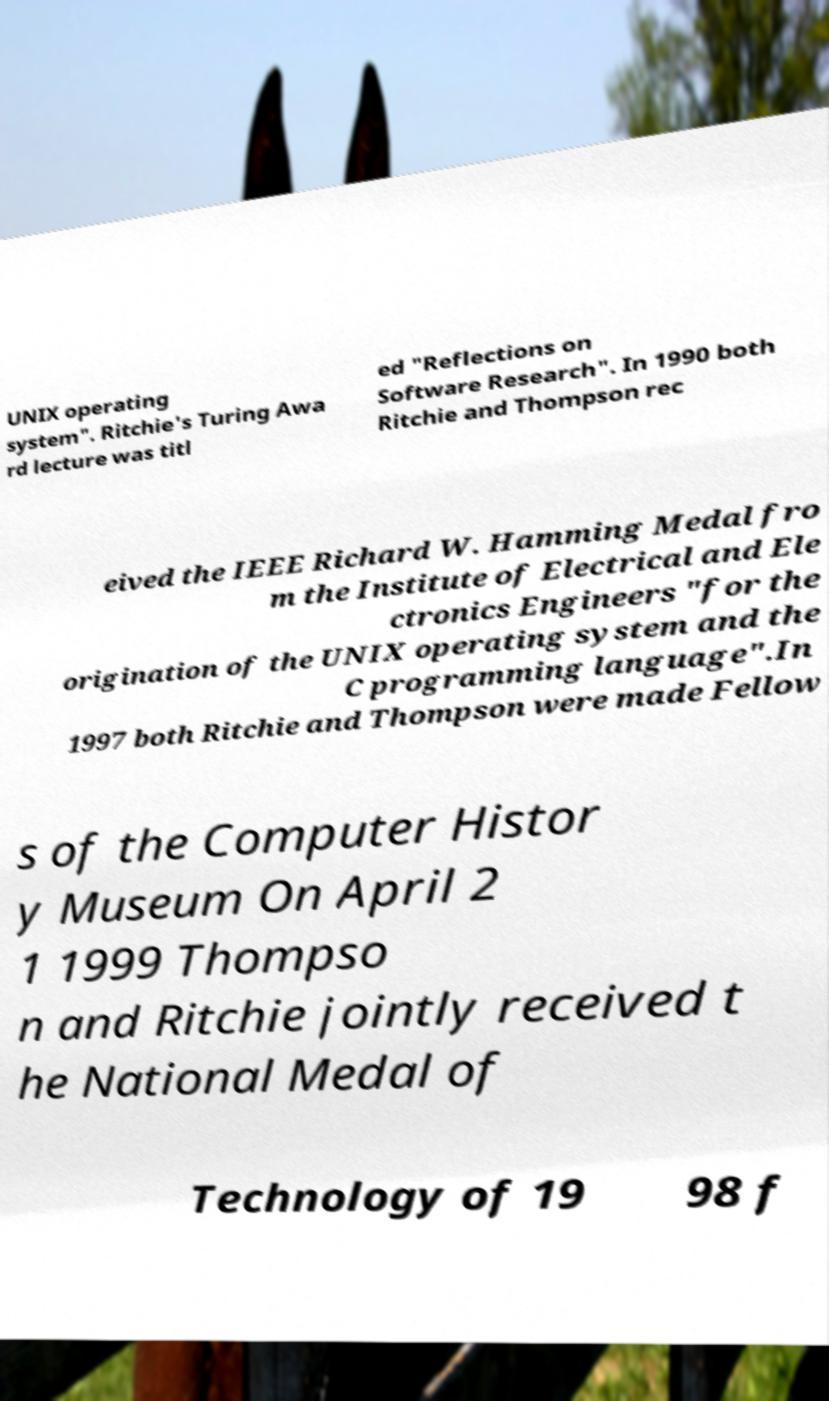Can you accurately transcribe the text from the provided image for me? UNIX operating system". Ritchie's Turing Awa rd lecture was titl ed "Reflections on Software Research". In 1990 both Ritchie and Thompson rec eived the IEEE Richard W. Hamming Medal fro m the Institute of Electrical and Ele ctronics Engineers "for the origination of the UNIX operating system and the C programming language".In 1997 both Ritchie and Thompson were made Fellow s of the Computer Histor y Museum On April 2 1 1999 Thompso n and Ritchie jointly received t he National Medal of Technology of 19 98 f 